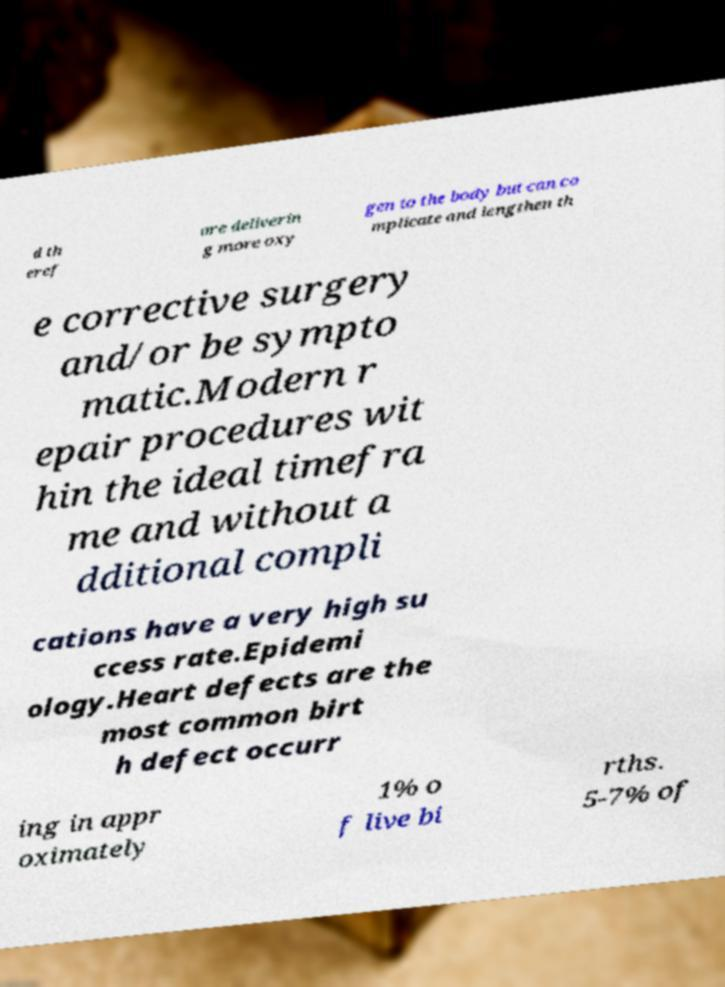For documentation purposes, I need the text within this image transcribed. Could you provide that? d th eref ore deliverin g more oxy gen to the body but can co mplicate and lengthen th e corrective surgery and/or be sympto matic.Modern r epair procedures wit hin the ideal timefra me and without a dditional compli cations have a very high su ccess rate.Epidemi ology.Heart defects are the most common birt h defect occurr ing in appr oximately 1% o f live bi rths. 5-7% of 